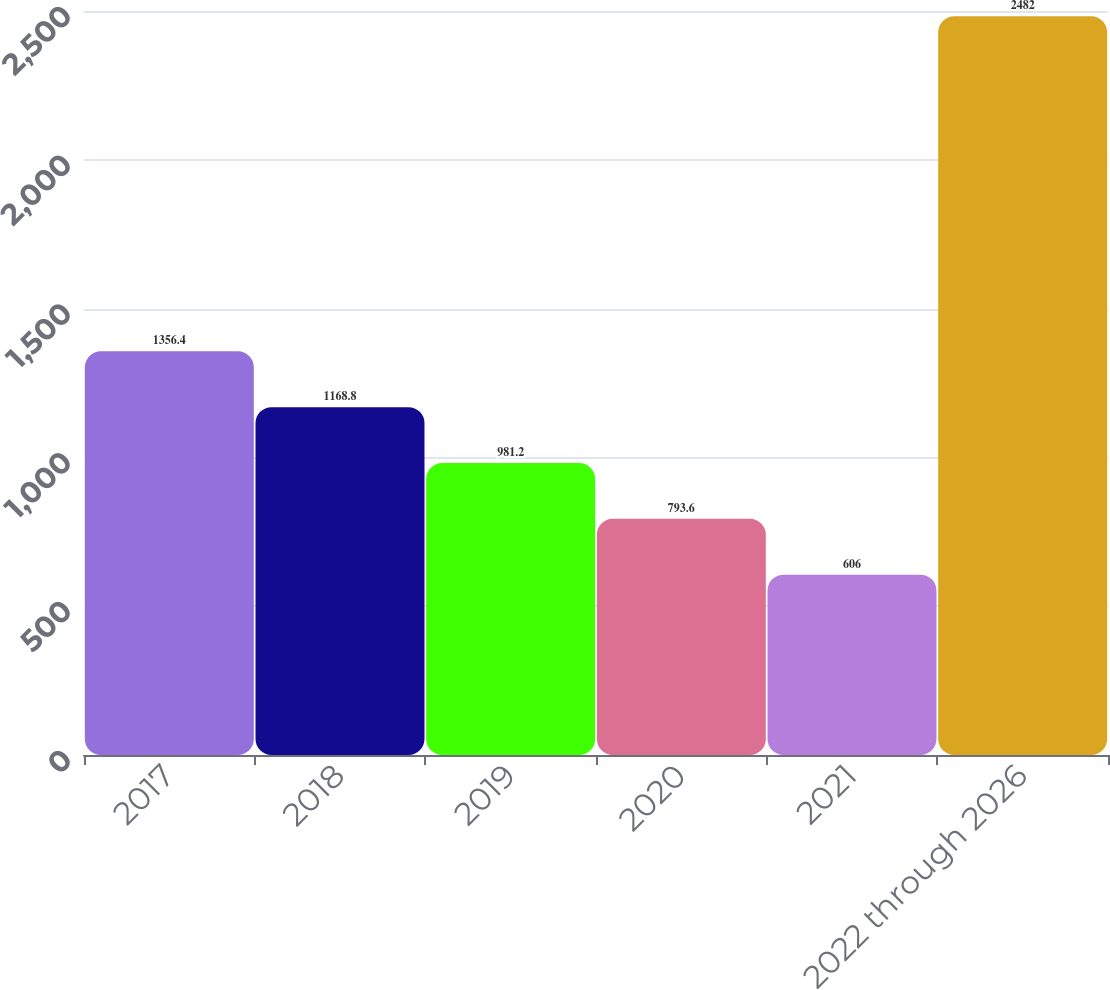Convert chart. <chart><loc_0><loc_0><loc_500><loc_500><bar_chart><fcel>2017<fcel>2018<fcel>2019<fcel>2020<fcel>2021<fcel>2022 through 2026<nl><fcel>1356.4<fcel>1168.8<fcel>981.2<fcel>793.6<fcel>606<fcel>2482<nl></chart> 